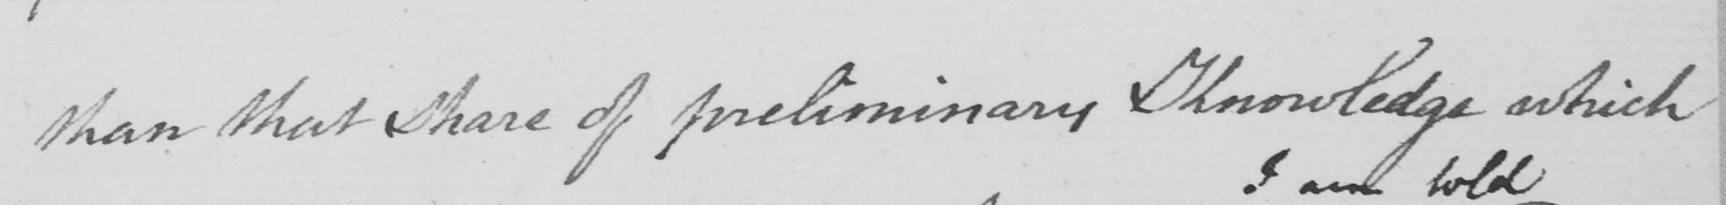What is written in this line of handwriting? than that share of preliminary Knowledge which 